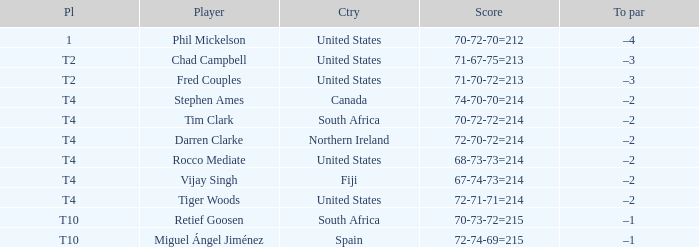Where is Fred Couples from? United States. 